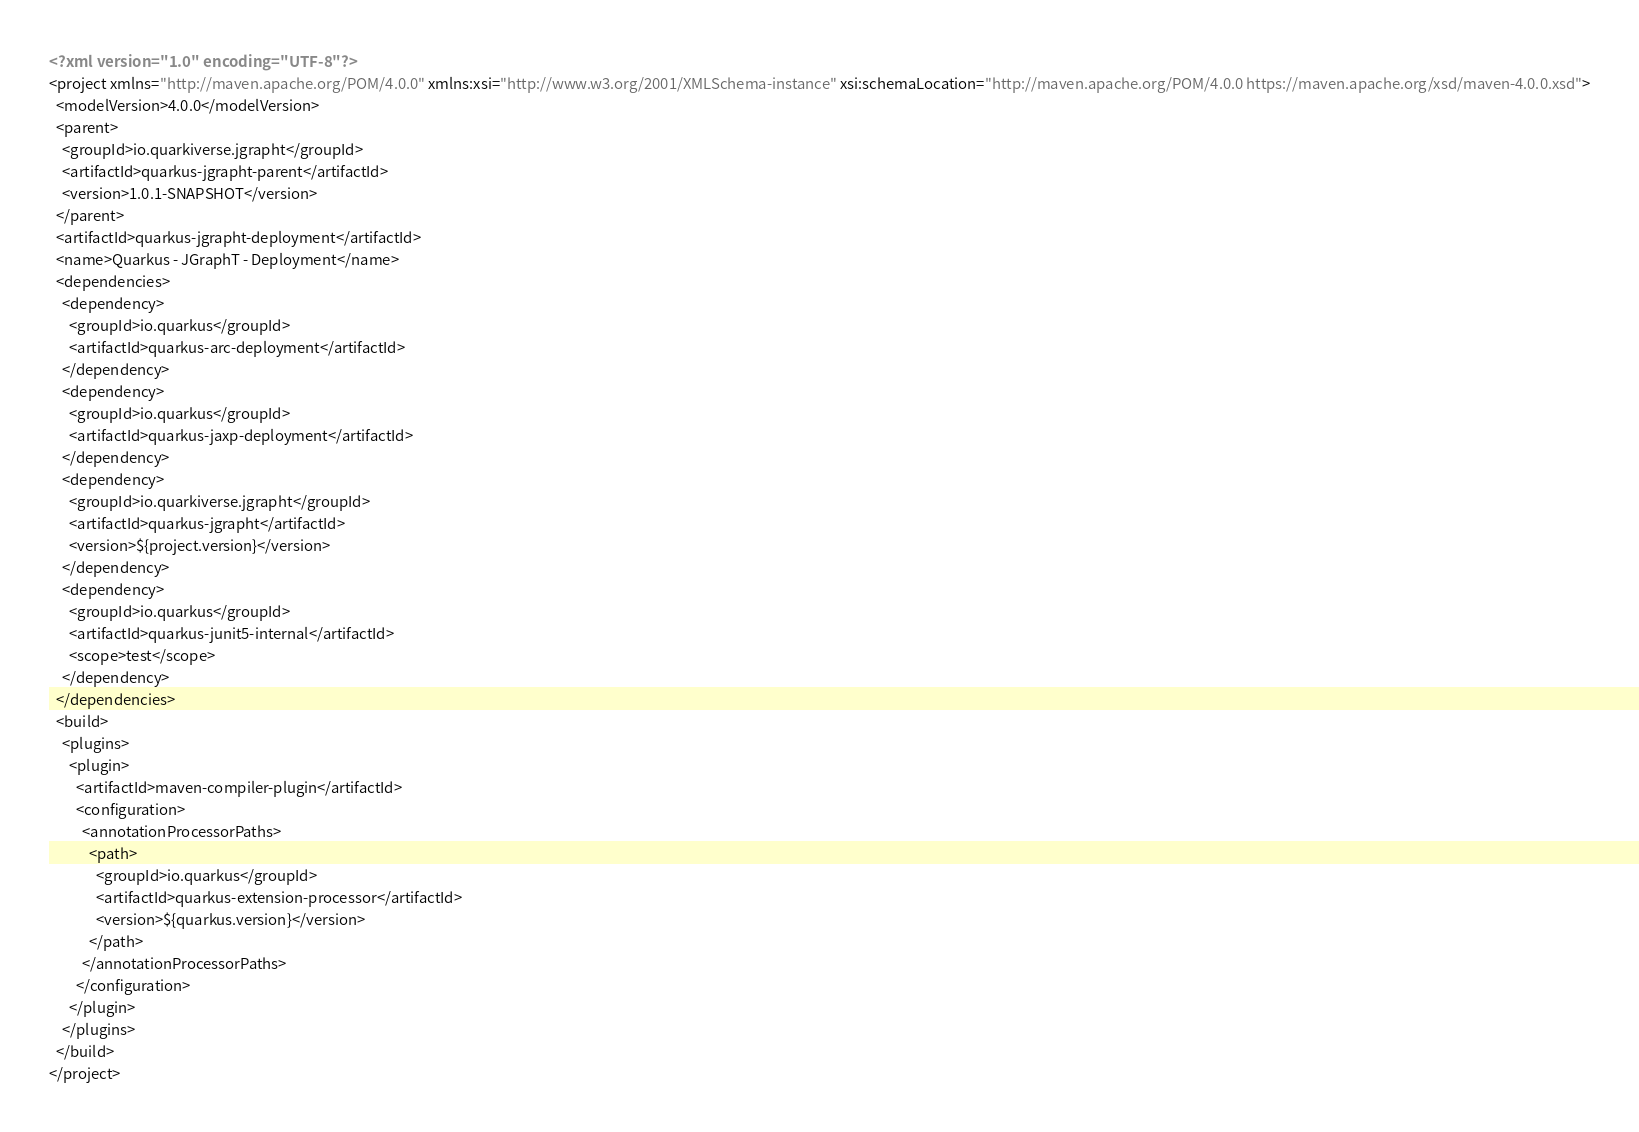Convert code to text. <code><loc_0><loc_0><loc_500><loc_500><_XML_><?xml version="1.0" encoding="UTF-8"?>
<project xmlns="http://maven.apache.org/POM/4.0.0" xmlns:xsi="http://www.w3.org/2001/XMLSchema-instance" xsi:schemaLocation="http://maven.apache.org/POM/4.0.0 https://maven.apache.org/xsd/maven-4.0.0.xsd">
  <modelVersion>4.0.0</modelVersion>
  <parent>
    <groupId>io.quarkiverse.jgrapht</groupId>
    <artifactId>quarkus-jgrapht-parent</artifactId>
    <version>1.0.1-SNAPSHOT</version>
  </parent>
  <artifactId>quarkus-jgrapht-deployment</artifactId>
  <name>Quarkus - JGraphT - Deployment</name>
  <dependencies>
    <dependency>
      <groupId>io.quarkus</groupId>
      <artifactId>quarkus-arc-deployment</artifactId>
    </dependency>
    <dependency>
      <groupId>io.quarkus</groupId>
      <artifactId>quarkus-jaxp-deployment</artifactId>
    </dependency>
    <dependency>
      <groupId>io.quarkiverse.jgrapht</groupId>
      <artifactId>quarkus-jgrapht</artifactId>
      <version>${project.version}</version>
    </dependency>
    <dependency>
      <groupId>io.quarkus</groupId>
      <artifactId>quarkus-junit5-internal</artifactId>
      <scope>test</scope>
    </dependency>
  </dependencies>
  <build>
    <plugins>
      <plugin>
        <artifactId>maven-compiler-plugin</artifactId>
        <configuration>
          <annotationProcessorPaths>
            <path>
              <groupId>io.quarkus</groupId>
              <artifactId>quarkus-extension-processor</artifactId>
              <version>${quarkus.version}</version>
            </path>
          </annotationProcessorPaths>
        </configuration>
      </plugin>
    </plugins>
  </build>
</project>
</code> 